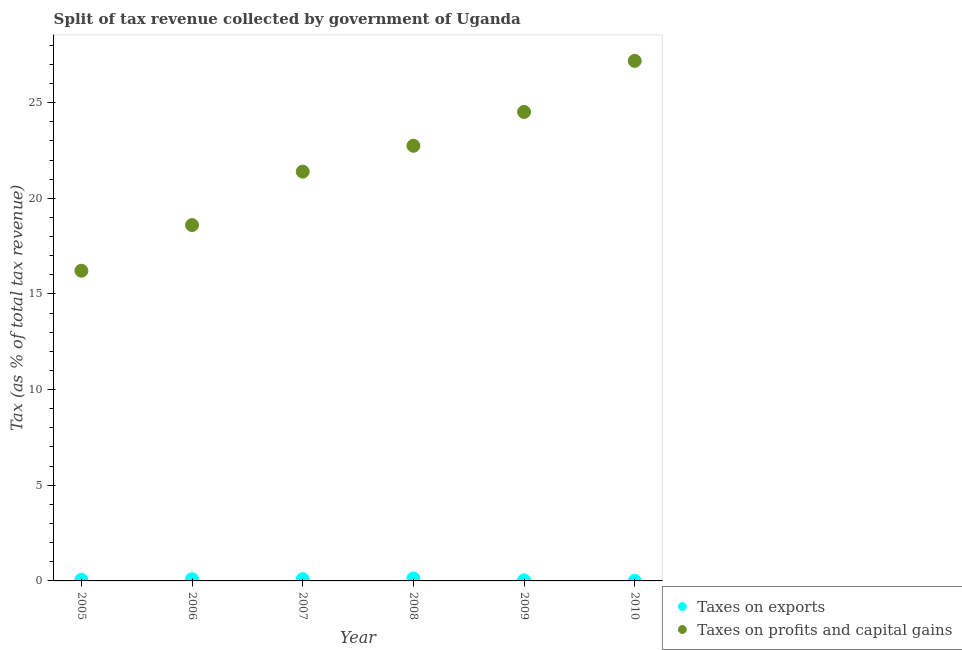How many different coloured dotlines are there?
Ensure brevity in your answer.  2. Is the number of dotlines equal to the number of legend labels?
Keep it short and to the point. Yes. What is the percentage of revenue obtained from taxes on profits and capital gains in 2007?
Provide a short and direct response. 21.39. Across all years, what is the maximum percentage of revenue obtained from taxes on exports?
Offer a very short reply. 0.13. Across all years, what is the minimum percentage of revenue obtained from taxes on exports?
Offer a terse response. 0. In which year was the percentage of revenue obtained from taxes on exports minimum?
Offer a terse response. 2010. What is the total percentage of revenue obtained from taxes on profits and capital gains in the graph?
Your response must be concise. 130.64. What is the difference between the percentage of revenue obtained from taxes on exports in 2005 and that in 2007?
Provide a succinct answer. -0.03. What is the difference between the percentage of revenue obtained from taxes on exports in 2010 and the percentage of revenue obtained from taxes on profits and capital gains in 2006?
Give a very brief answer. -18.6. What is the average percentage of revenue obtained from taxes on profits and capital gains per year?
Keep it short and to the point. 21.77. In the year 2007, what is the difference between the percentage of revenue obtained from taxes on profits and capital gains and percentage of revenue obtained from taxes on exports?
Give a very brief answer. 21.3. In how many years, is the percentage of revenue obtained from taxes on profits and capital gains greater than 27 %?
Your answer should be compact. 1. What is the ratio of the percentage of revenue obtained from taxes on exports in 2005 to that in 2008?
Provide a short and direct response. 0.47. Is the difference between the percentage of revenue obtained from taxes on exports in 2006 and 2007 greater than the difference between the percentage of revenue obtained from taxes on profits and capital gains in 2006 and 2007?
Ensure brevity in your answer.  Yes. What is the difference between the highest and the second highest percentage of revenue obtained from taxes on exports?
Provide a succinct answer. 0.04. What is the difference between the highest and the lowest percentage of revenue obtained from taxes on profits and capital gains?
Provide a succinct answer. 10.97. Does the percentage of revenue obtained from taxes on exports monotonically increase over the years?
Make the answer very short. No. Is the percentage of revenue obtained from taxes on exports strictly less than the percentage of revenue obtained from taxes on profits and capital gains over the years?
Keep it short and to the point. Yes. How many dotlines are there?
Your answer should be compact. 2. How many years are there in the graph?
Your answer should be very brief. 6. Are the values on the major ticks of Y-axis written in scientific E-notation?
Ensure brevity in your answer.  No. Does the graph contain any zero values?
Your response must be concise. No. How many legend labels are there?
Make the answer very short. 2. How are the legend labels stacked?
Your answer should be compact. Vertical. What is the title of the graph?
Your answer should be compact. Split of tax revenue collected by government of Uganda. What is the label or title of the Y-axis?
Make the answer very short. Tax (as % of total tax revenue). What is the Tax (as % of total tax revenue) of Taxes on exports in 2005?
Ensure brevity in your answer.  0.06. What is the Tax (as % of total tax revenue) of Taxes on profits and capital gains in 2005?
Offer a terse response. 16.21. What is the Tax (as % of total tax revenue) in Taxes on exports in 2006?
Offer a very short reply. 0.09. What is the Tax (as % of total tax revenue) in Taxes on profits and capital gains in 2006?
Your answer should be compact. 18.6. What is the Tax (as % of total tax revenue) in Taxes on exports in 2007?
Offer a terse response. 0.09. What is the Tax (as % of total tax revenue) in Taxes on profits and capital gains in 2007?
Offer a terse response. 21.39. What is the Tax (as % of total tax revenue) in Taxes on exports in 2008?
Provide a short and direct response. 0.13. What is the Tax (as % of total tax revenue) of Taxes on profits and capital gains in 2008?
Provide a succinct answer. 22.74. What is the Tax (as % of total tax revenue) of Taxes on exports in 2009?
Give a very brief answer. 0.03. What is the Tax (as % of total tax revenue) in Taxes on profits and capital gains in 2009?
Your answer should be very brief. 24.51. What is the Tax (as % of total tax revenue) in Taxes on exports in 2010?
Make the answer very short. 0. What is the Tax (as % of total tax revenue) in Taxes on profits and capital gains in 2010?
Your response must be concise. 27.18. Across all years, what is the maximum Tax (as % of total tax revenue) of Taxes on exports?
Your answer should be very brief. 0.13. Across all years, what is the maximum Tax (as % of total tax revenue) of Taxes on profits and capital gains?
Ensure brevity in your answer.  27.18. Across all years, what is the minimum Tax (as % of total tax revenue) in Taxes on exports?
Your answer should be very brief. 0. Across all years, what is the minimum Tax (as % of total tax revenue) of Taxes on profits and capital gains?
Your answer should be very brief. 16.21. What is the total Tax (as % of total tax revenue) of Taxes on exports in the graph?
Offer a very short reply. 0.41. What is the total Tax (as % of total tax revenue) of Taxes on profits and capital gains in the graph?
Provide a succinct answer. 130.64. What is the difference between the Tax (as % of total tax revenue) of Taxes on exports in 2005 and that in 2006?
Your answer should be very brief. -0.03. What is the difference between the Tax (as % of total tax revenue) in Taxes on profits and capital gains in 2005 and that in 2006?
Offer a terse response. -2.39. What is the difference between the Tax (as % of total tax revenue) of Taxes on exports in 2005 and that in 2007?
Provide a succinct answer. -0.03. What is the difference between the Tax (as % of total tax revenue) of Taxes on profits and capital gains in 2005 and that in 2007?
Ensure brevity in your answer.  -5.18. What is the difference between the Tax (as % of total tax revenue) of Taxes on exports in 2005 and that in 2008?
Give a very brief answer. -0.07. What is the difference between the Tax (as % of total tax revenue) in Taxes on profits and capital gains in 2005 and that in 2008?
Keep it short and to the point. -6.53. What is the difference between the Tax (as % of total tax revenue) in Taxes on exports in 2005 and that in 2009?
Provide a succinct answer. 0.03. What is the difference between the Tax (as % of total tax revenue) of Taxes on profits and capital gains in 2005 and that in 2009?
Your answer should be very brief. -8.3. What is the difference between the Tax (as % of total tax revenue) of Taxes on exports in 2005 and that in 2010?
Offer a very short reply. 0.06. What is the difference between the Tax (as % of total tax revenue) in Taxes on profits and capital gains in 2005 and that in 2010?
Provide a succinct answer. -10.97. What is the difference between the Tax (as % of total tax revenue) of Taxes on exports in 2006 and that in 2007?
Your answer should be compact. -0. What is the difference between the Tax (as % of total tax revenue) of Taxes on profits and capital gains in 2006 and that in 2007?
Your response must be concise. -2.79. What is the difference between the Tax (as % of total tax revenue) of Taxes on exports in 2006 and that in 2008?
Your response must be concise. -0.04. What is the difference between the Tax (as % of total tax revenue) in Taxes on profits and capital gains in 2006 and that in 2008?
Make the answer very short. -4.14. What is the difference between the Tax (as % of total tax revenue) of Taxes on exports in 2006 and that in 2009?
Give a very brief answer. 0.06. What is the difference between the Tax (as % of total tax revenue) in Taxes on profits and capital gains in 2006 and that in 2009?
Your answer should be compact. -5.91. What is the difference between the Tax (as % of total tax revenue) in Taxes on exports in 2006 and that in 2010?
Your answer should be compact. 0.09. What is the difference between the Tax (as % of total tax revenue) in Taxes on profits and capital gains in 2006 and that in 2010?
Offer a terse response. -8.58. What is the difference between the Tax (as % of total tax revenue) in Taxes on exports in 2007 and that in 2008?
Give a very brief answer. -0.04. What is the difference between the Tax (as % of total tax revenue) of Taxes on profits and capital gains in 2007 and that in 2008?
Ensure brevity in your answer.  -1.35. What is the difference between the Tax (as % of total tax revenue) in Taxes on exports in 2007 and that in 2009?
Offer a terse response. 0.06. What is the difference between the Tax (as % of total tax revenue) of Taxes on profits and capital gains in 2007 and that in 2009?
Provide a succinct answer. -3.12. What is the difference between the Tax (as % of total tax revenue) of Taxes on exports in 2007 and that in 2010?
Your answer should be very brief. 0.09. What is the difference between the Tax (as % of total tax revenue) of Taxes on profits and capital gains in 2007 and that in 2010?
Offer a terse response. -5.79. What is the difference between the Tax (as % of total tax revenue) of Taxes on exports in 2008 and that in 2009?
Your answer should be very brief. 0.1. What is the difference between the Tax (as % of total tax revenue) in Taxes on profits and capital gains in 2008 and that in 2009?
Keep it short and to the point. -1.77. What is the difference between the Tax (as % of total tax revenue) in Taxes on exports in 2008 and that in 2010?
Provide a succinct answer. 0.13. What is the difference between the Tax (as % of total tax revenue) in Taxes on profits and capital gains in 2008 and that in 2010?
Provide a succinct answer. -4.44. What is the difference between the Tax (as % of total tax revenue) of Taxes on exports in 2009 and that in 2010?
Your response must be concise. 0.03. What is the difference between the Tax (as % of total tax revenue) of Taxes on profits and capital gains in 2009 and that in 2010?
Offer a terse response. -2.67. What is the difference between the Tax (as % of total tax revenue) of Taxes on exports in 2005 and the Tax (as % of total tax revenue) of Taxes on profits and capital gains in 2006?
Offer a terse response. -18.54. What is the difference between the Tax (as % of total tax revenue) in Taxes on exports in 2005 and the Tax (as % of total tax revenue) in Taxes on profits and capital gains in 2007?
Give a very brief answer. -21.33. What is the difference between the Tax (as % of total tax revenue) of Taxes on exports in 2005 and the Tax (as % of total tax revenue) of Taxes on profits and capital gains in 2008?
Make the answer very short. -22.68. What is the difference between the Tax (as % of total tax revenue) of Taxes on exports in 2005 and the Tax (as % of total tax revenue) of Taxes on profits and capital gains in 2009?
Offer a very short reply. -24.45. What is the difference between the Tax (as % of total tax revenue) in Taxes on exports in 2005 and the Tax (as % of total tax revenue) in Taxes on profits and capital gains in 2010?
Offer a terse response. -27.12. What is the difference between the Tax (as % of total tax revenue) in Taxes on exports in 2006 and the Tax (as % of total tax revenue) in Taxes on profits and capital gains in 2007?
Ensure brevity in your answer.  -21.3. What is the difference between the Tax (as % of total tax revenue) of Taxes on exports in 2006 and the Tax (as % of total tax revenue) of Taxes on profits and capital gains in 2008?
Ensure brevity in your answer.  -22.65. What is the difference between the Tax (as % of total tax revenue) in Taxes on exports in 2006 and the Tax (as % of total tax revenue) in Taxes on profits and capital gains in 2009?
Give a very brief answer. -24.42. What is the difference between the Tax (as % of total tax revenue) of Taxes on exports in 2006 and the Tax (as % of total tax revenue) of Taxes on profits and capital gains in 2010?
Offer a terse response. -27.09. What is the difference between the Tax (as % of total tax revenue) in Taxes on exports in 2007 and the Tax (as % of total tax revenue) in Taxes on profits and capital gains in 2008?
Offer a terse response. -22.65. What is the difference between the Tax (as % of total tax revenue) in Taxes on exports in 2007 and the Tax (as % of total tax revenue) in Taxes on profits and capital gains in 2009?
Your response must be concise. -24.42. What is the difference between the Tax (as % of total tax revenue) of Taxes on exports in 2007 and the Tax (as % of total tax revenue) of Taxes on profits and capital gains in 2010?
Ensure brevity in your answer.  -27.09. What is the difference between the Tax (as % of total tax revenue) in Taxes on exports in 2008 and the Tax (as % of total tax revenue) in Taxes on profits and capital gains in 2009?
Provide a succinct answer. -24.38. What is the difference between the Tax (as % of total tax revenue) of Taxes on exports in 2008 and the Tax (as % of total tax revenue) of Taxes on profits and capital gains in 2010?
Offer a very short reply. -27.05. What is the difference between the Tax (as % of total tax revenue) in Taxes on exports in 2009 and the Tax (as % of total tax revenue) in Taxes on profits and capital gains in 2010?
Ensure brevity in your answer.  -27.15. What is the average Tax (as % of total tax revenue) of Taxes on exports per year?
Ensure brevity in your answer.  0.07. What is the average Tax (as % of total tax revenue) of Taxes on profits and capital gains per year?
Offer a very short reply. 21.77. In the year 2005, what is the difference between the Tax (as % of total tax revenue) of Taxes on exports and Tax (as % of total tax revenue) of Taxes on profits and capital gains?
Your answer should be compact. -16.15. In the year 2006, what is the difference between the Tax (as % of total tax revenue) in Taxes on exports and Tax (as % of total tax revenue) in Taxes on profits and capital gains?
Offer a very short reply. -18.51. In the year 2007, what is the difference between the Tax (as % of total tax revenue) of Taxes on exports and Tax (as % of total tax revenue) of Taxes on profits and capital gains?
Offer a very short reply. -21.3. In the year 2008, what is the difference between the Tax (as % of total tax revenue) in Taxes on exports and Tax (as % of total tax revenue) in Taxes on profits and capital gains?
Offer a very short reply. -22.62. In the year 2009, what is the difference between the Tax (as % of total tax revenue) of Taxes on exports and Tax (as % of total tax revenue) of Taxes on profits and capital gains?
Ensure brevity in your answer.  -24.48. In the year 2010, what is the difference between the Tax (as % of total tax revenue) of Taxes on exports and Tax (as % of total tax revenue) of Taxes on profits and capital gains?
Give a very brief answer. -27.18. What is the ratio of the Tax (as % of total tax revenue) of Taxes on exports in 2005 to that in 2006?
Give a very brief answer. 0.66. What is the ratio of the Tax (as % of total tax revenue) of Taxes on profits and capital gains in 2005 to that in 2006?
Make the answer very short. 0.87. What is the ratio of the Tax (as % of total tax revenue) of Taxes on exports in 2005 to that in 2007?
Ensure brevity in your answer.  0.65. What is the ratio of the Tax (as % of total tax revenue) in Taxes on profits and capital gains in 2005 to that in 2007?
Give a very brief answer. 0.76. What is the ratio of the Tax (as % of total tax revenue) of Taxes on exports in 2005 to that in 2008?
Offer a very short reply. 0.47. What is the ratio of the Tax (as % of total tax revenue) in Taxes on profits and capital gains in 2005 to that in 2008?
Your response must be concise. 0.71. What is the ratio of the Tax (as % of total tax revenue) in Taxes on exports in 2005 to that in 2009?
Provide a short and direct response. 1.94. What is the ratio of the Tax (as % of total tax revenue) in Taxes on profits and capital gains in 2005 to that in 2009?
Make the answer very short. 0.66. What is the ratio of the Tax (as % of total tax revenue) in Taxes on exports in 2005 to that in 2010?
Offer a terse response. 20.84. What is the ratio of the Tax (as % of total tax revenue) in Taxes on profits and capital gains in 2005 to that in 2010?
Provide a short and direct response. 0.6. What is the ratio of the Tax (as % of total tax revenue) of Taxes on exports in 2006 to that in 2007?
Offer a terse response. 0.99. What is the ratio of the Tax (as % of total tax revenue) of Taxes on profits and capital gains in 2006 to that in 2007?
Offer a terse response. 0.87. What is the ratio of the Tax (as % of total tax revenue) in Taxes on exports in 2006 to that in 2008?
Your response must be concise. 0.71. What is the ratio of the Tax (as % of total tax revenue) of Taxes on profits and capital gains in 2006 to that in 2008?
Your answer should be very brief. 0.82. What is the ratio of the Tax (as % of total tax revenue) in Taxes on exports in 2006 to that in 2009?
Provide a succinct answer. 2.94. What is the ratio of the Tax (as % of total tax revenue) in Taxes on profits and capital gains in 2006 to that in 2009?
Your response must be concise. 0.76. What is the ratio of the Tax (as % of total tax revenue) in Taxes on exports in 2006 to that in 2010?
Ensure brevity in your answer.  31.54. What is the ratio of the Tax (as % of total tax revenue) in Taxes on profits and capital gains in 2006 to that in 2010?
Keep it short and to the point. 0.68. What is the ratio of the Tax (as % of total tax revenue) of Taxes on exports in 2007 to that in 2008?
Your answer should be very brief. 0.72. What is the ratio of the Tax (as % of total tax revenue) of Taxes on profits and capital gains in 2007 to that in 2008?
Ensure brevity in your answer.  0.94. What is the ratio of the Tax (as % of total tax revenue) of Taxes on exports in 2007 to that in 2009?
Offer a terse response. 2.98. What is the ratio of the Tax (as % of total tax revenue) in Taxes on profits and capital gains in 2007 to that in 2009?
Provide a succinct answer. 0.87. What is the ratio of the Tax (as % of total tax revenue) in Taxes on exports in 2007 to that in 2010?
Provide a short and direct response. 31.99. What is the ratio of the Tax (as % of total tax revenue) in Taxes on profits and capital gains in 2007 to that in 2010?
Provide a succinct answer. 0.79. What is the ratio of the Tax (as % of total tax revenue) of Taxes on exports in 2008 to that in 2009?
Offer a very short reply. 4.15. What is the ratio of the Tax (as % of total tax revenue) in Taxes on profits and capital gains in 2008 to that in 2009?
Give a very brief answer. 0.93. What is the ratio of the Tax (as % of total tax revenue) of Taxes on exports in 2008 to that in 2010?
Provide a succinct answer. 44.5. What is the ratio of the Tax (as % of total tax revenue) of Taxes on profits and capital gains in 2008 to that in 2010?
Ensure brevity in your answer.  0.84. What is the ratio of the Tax (as % of total tax revenue) of Taxes on exports in 2009 to that in 2010?
Your answer should be compact. 10.72. What is the ratio of the Tax (as % of total tax revenue) in Taxes on profits and capital gains in 2009 to that in 2010?
Provide a short and direct response. 0.9. What is the difference between the highest and the second highest Tax (as % of total tax revenue) of Taxes on exports?
Your answer should be very brief. 0.04. What is the difference between the highest and the second highest Tax (as % of total tax revenue) in Taxes on profits and capital gains?
Provide a short and direct response. 2.67. What is the difference between the highest and the lowest Tax (as % of total tax revenue) of Taxes on exports?
Give a very brief answer. 0.13. What is the difference between the highest and the lowest Tax (as % of total tax revenue) in Taxes on profits and capital gains?
Your response must be concise. 10.97. 